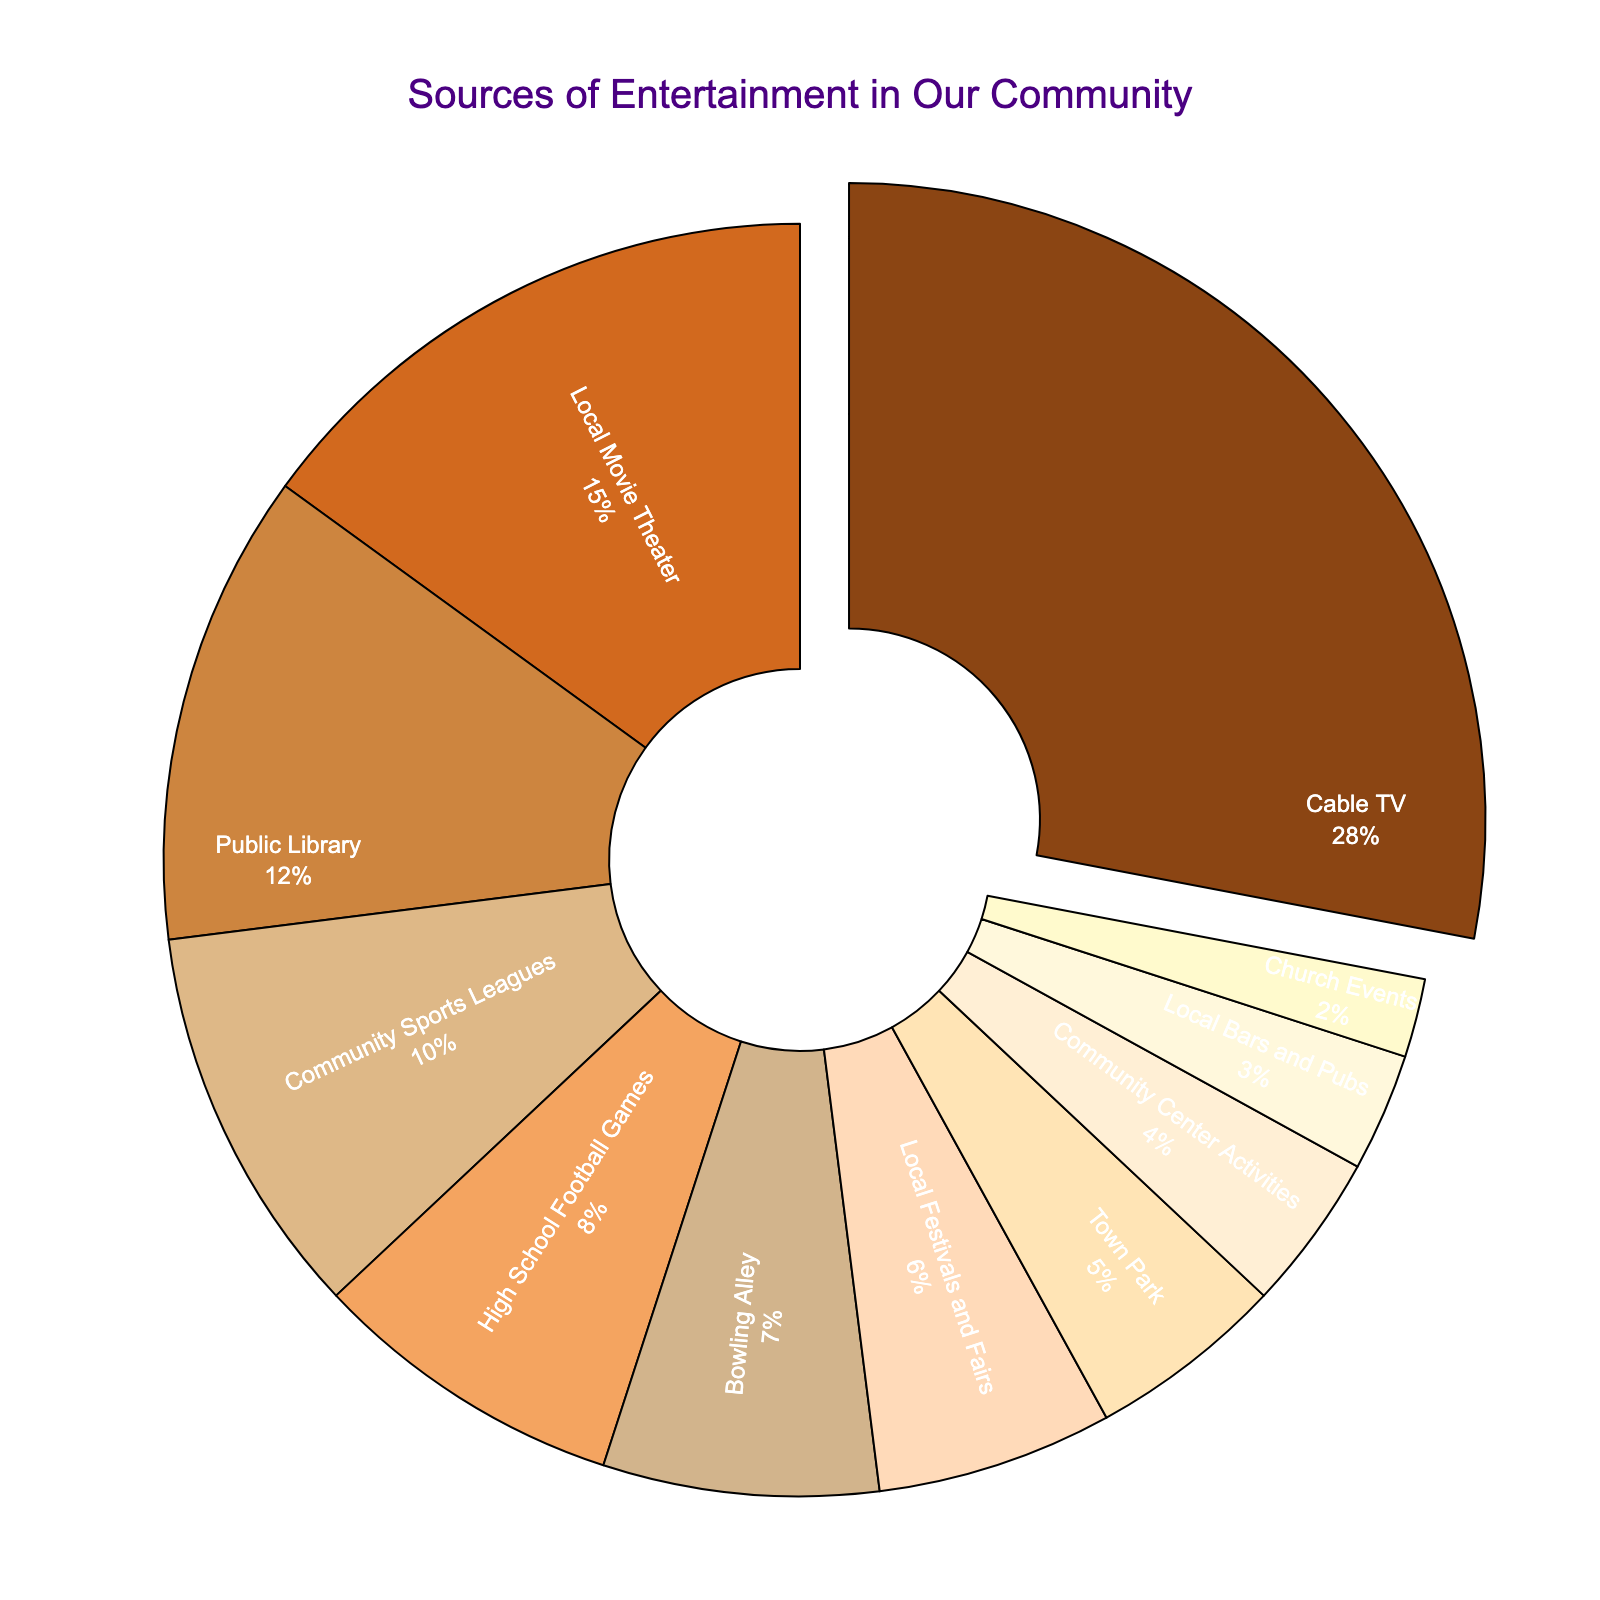Which source of entertainment has the largest percentage? The figure shows that Cable TV occupies the largest segment of the pie chart.
Answer: Cable TV What percentage of entertainment comes from Local Movie Theater and Public Library combined? The percentage for Local Movie Theater is 15%, and for Public Library it is 12%. The sum is calculated as 15 + 12.
Answer: 27% Which source provides more entertainment, Community Sports Leagues or High School Football Games? From the figure, Community Sports Leagues have a larger segment compared to High School Football Games. Specifically, Community Sports Leagues have 10% while High School Football Games have 8%.
Answer: Community Sports Leagues How much larger is the entertainment percentage for Cable TV compared to Local Festivals and Fairs? Cable TV is 28% and Local Festivals and Fairs are 6%. The difference is calculated as 28 - 6.
Answer: 22% What is the combined percentage for all community-related activities like Community Sports Leagues, High School Football Games, Town Park, and Community Center Activities? Adding the percentages for Community Sports Leagues (10%), High School Football Games (8%), Town Park (5%), and Community Center Activities (4%) results in 10 + 8 + 5 + 4.
Answer: 27% Which source of entertainment contributes the least percentage and what is that percentage? The figure shows that Church Events have the smallest segment in the pie chart, which is 2%.
Answer: Church Events, 2% Is the percentage of entertainment from Local Bars and Pubs more than from Bowling Alley? The figure shows that Bowling Alley has a percentage of 7%, whereas Local Bars and Pubs have 3%. Since 7% is greater than 3%, Bowling Alley provides more entertainment.
Answer: No How do the combined percentages of Local Movie Theater and High School Football Games compare to Cable TV? Adding the percentages of Local Movie Theater (15%) and High School Football Games (8%) gives 15 + 8 = 23%, which is less than the 28% for Cable TV.
Answer: Less If we group Church Events, Local Bars and Pubs, and Community Center Activities together, what is their combined percentage? Church Events have 2%, Local Bars and Pubs have 3%, and Community Center Activities have 4%. The sum is 2 + 3 + 4.
Answer: 9% What is the total percentage of less prominent sources (those with a percentage less than 10%)? Local Movie Theater (15%), Public Library (12%), and Community Sports Leagues (10%) are excluded. Adding the rest: High School Football Games (8%) + Bowling Alley (7%) + Local Festivals and Fairs (6%) + Town Park (5%) + Community Center Activities (4%) + Local Bars and Pubs (3%) + Church Events (2%) gives 8 + 7 + 6 + 5 + 4 + 3 + 2.
Answer: 35% 